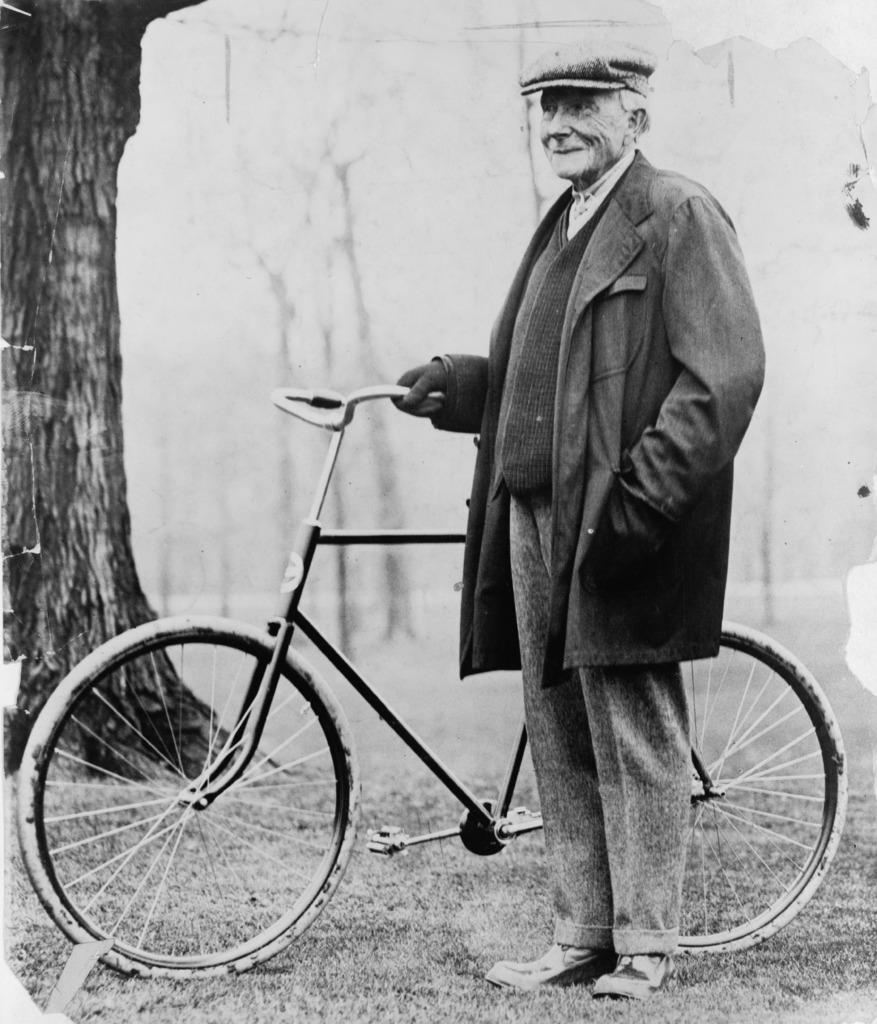Describe this image in one or two sentences. In this picture we can see a old man holding a bicycle, he is wearing a hat and blazer. In the background we can find some trees. 